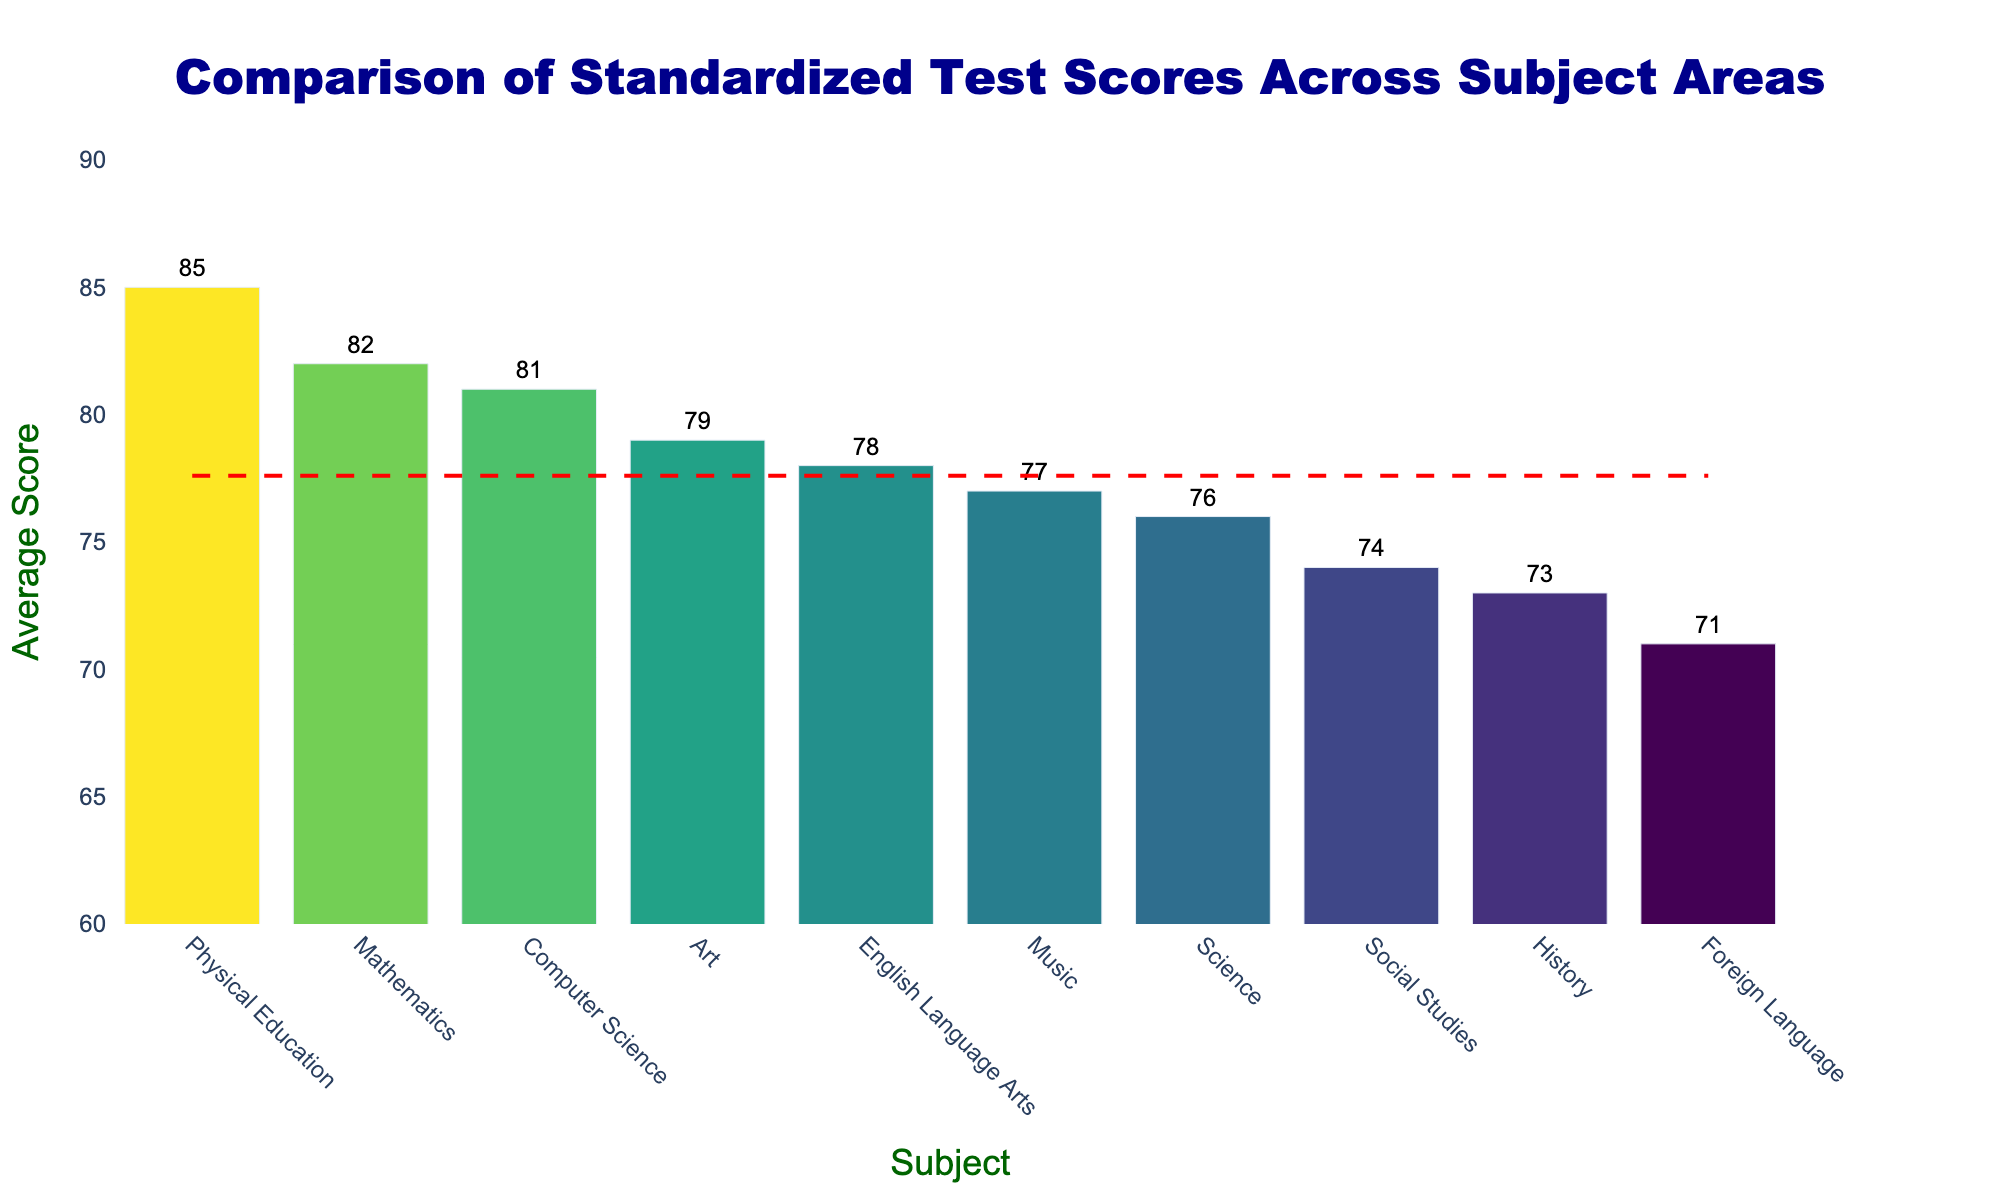Which subject has the highest average score? The subject with the highest bar on the chart represents the one with the highest average score. Here, Physical Education has the highest bar.
Answer: Physical Education Which subject has the lowest average score? The subject with the lowest bar on the chart represents the one with the lowest average score. Here, Foreign Language has the lowest bar.
Answer: Foreign Language How does the average score in Mathematics compare to that in English Language Arts? Mathematics and English Language Arts are adjacent in the sorted bar chart, with Mathematics having an average score of 82 and English Language Arts having 78, showing that Mathematics is higher.
Answer: Mathematics has a higher score What is the range of the average scores across all subjects? To calculate the range, subtract the lowest average score from the highest average score. Here, the lowest average score is 71 (Foreign Language) and the highest is 85 (Physical Education), so the range is 85 - 71.
Answer: 14 Is the average score in Computer Science higher than the overall average score? The red dashed line represents the overall average score. Comparing it with the bar for Computer Science, which has an average score of 81, we see that Computer Science is higher as the bar is above the line.
Answer: Yes What is the difference between the average score in Science and History? The average score in Science is 76, and in History, it's 73. Subtract the lower score from the higher score: 76 - 73.
Answer: 3 How many subjects have an average score above 80? Counting the bars that extend above the 80 mark on the y-axis, we find that they belong to Physical Education, Mathematics, and Computer Science.
Answer: 3 Which subject is just below the average score line, and what is its score? The bar just below the red dashed line is Music, with an average score of 77.
Answer: Music, 77 How does the score in Art compare to the average score? The average score in Art is 79, which is slightly above the red dashed line, indicating it is above the average score.
Answer: Above average What is the sum of the average scores in all subjects? Add up all the average scores: 82 (Mathematics) + 78 (English Language Arts) + 76 (Science) + 74 (Social Studies) + 71 (Foreign Language) + 85 (Physical Education) + 79 (Art) + 77 (Music) + 81 (Computer Science) + 73 (History). The sum is 776.
Answer: 776 